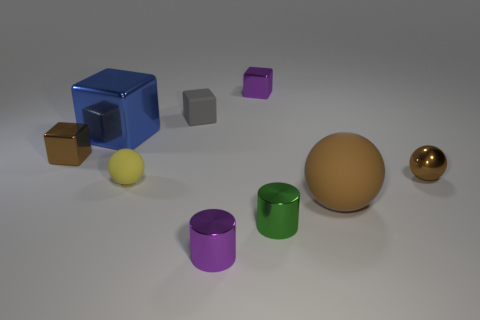Subtract all cylinders. How many objects are left? 7 Add 2 big matte balls. How many big matte balls are left? 3 Add 3 brown matte things. How many brown matte things exist? 4 Subtract 0 cyan cylinders. How many objects are left? 9 Subtract all small purple shiny cylinders. Subtract all brown shiny blocks. How many objects are left? 7 